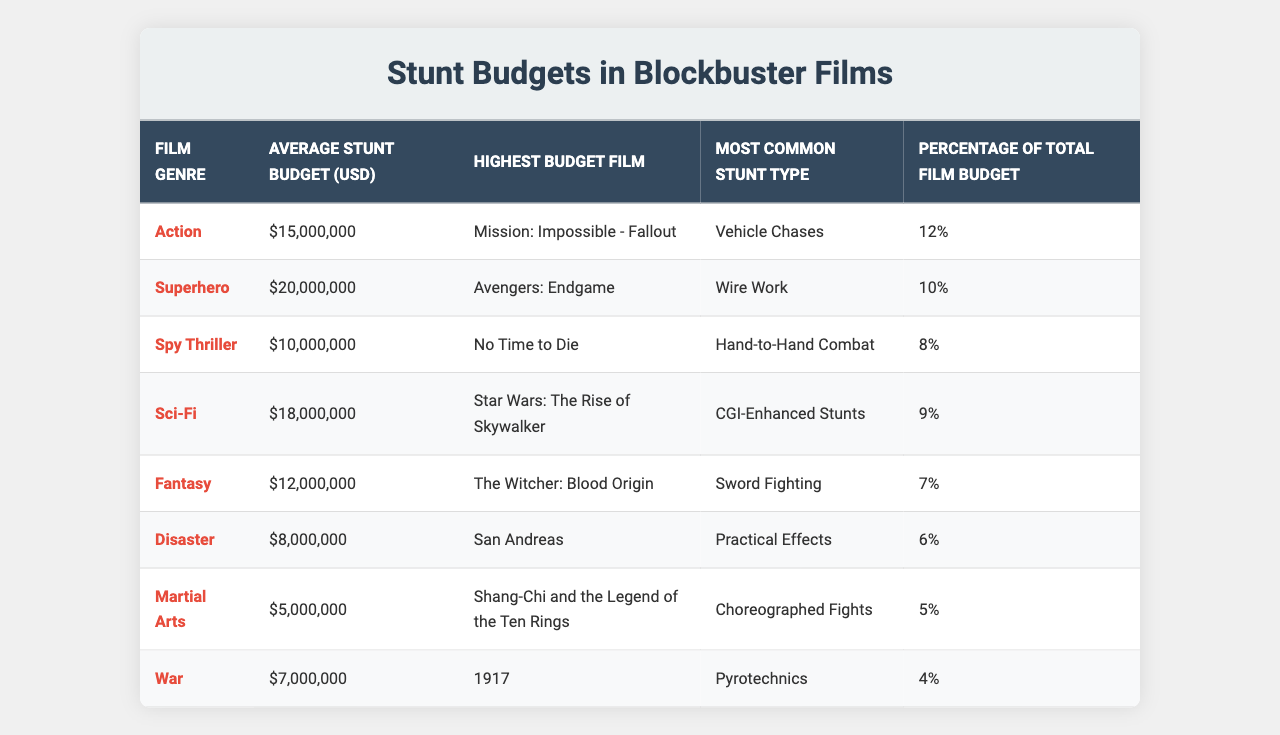What is the average stunt budget for superhero films? The table indicates that the average stunt budget for superhero films is $20,000,000.
Answer: $20,000,000 Which film had the highest stunt budget among action films? According to the table, "Mission: Impossible - Fallout" had the highest stunt budget within the action genre.
Answer: Mission: Impossible - Fallout What is the most common stunt type in sci-fi films? The table lists "CGI-Enhanced Stunts" as the most common stunt type for sci-fi films.
Answer: CGI-Enhanced Stunts Is the average stunt budget for fantasy films higher than that for disaster films? The average stunt budget for fantasy films is $12,000,000 while for disaster films it is $8,000,000, so yes, fantasy films have a higher budget.
Answer: Yes What percentage of the total film budget is allocated for stunts in spy thriller films? The table shows that 8% of the total film budget is used for stunts in spy thriller films.
Answer: 8% What is the difference in average stunt budgets between superhero and martial arts films? The average stunt budget for superhero films is $20,000,000 and for martial arts films is $5,000,000; therefore, the difference is $20,000,000 - $5,000,000 = $15,000,000.
Answer: $15,000,000 How many genres have an average stunt budget of over $15 million? The genres that meet this criterion are Action, Superhero, and Sci-Fi, totaling 3 genres.
Answer: 3 Is the percentage of the total film budget for stunts higher in superhero films compared to action films? Superhero films allocate 10% of their total budget for stunts, whereas action films allocate 12%, so it is not higher.
Answer: No Among the listed genres, which has the lowest average stunt budget and what is it? The martial arts genre has the lowest average stunt budget at $5,000,000.
Answer: $5,000,000 If you combine the average stunt budgets of sci-fi and fantasy films, what would that total be? The average stunt budget for sci-fi films is $18,000,000 and for fantasy it is $12,000,000; combining these gives $18,000,000 + $12,000,000 = $30,000,000.
Answer: $30,000,000 